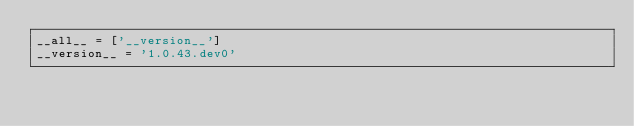Convert code to text. <code><loc_0><loc_0><loc_500><loc_500><_Python_>__all__ = ['__version__']
__version__ = '1.0.43.dev0'
</code> 